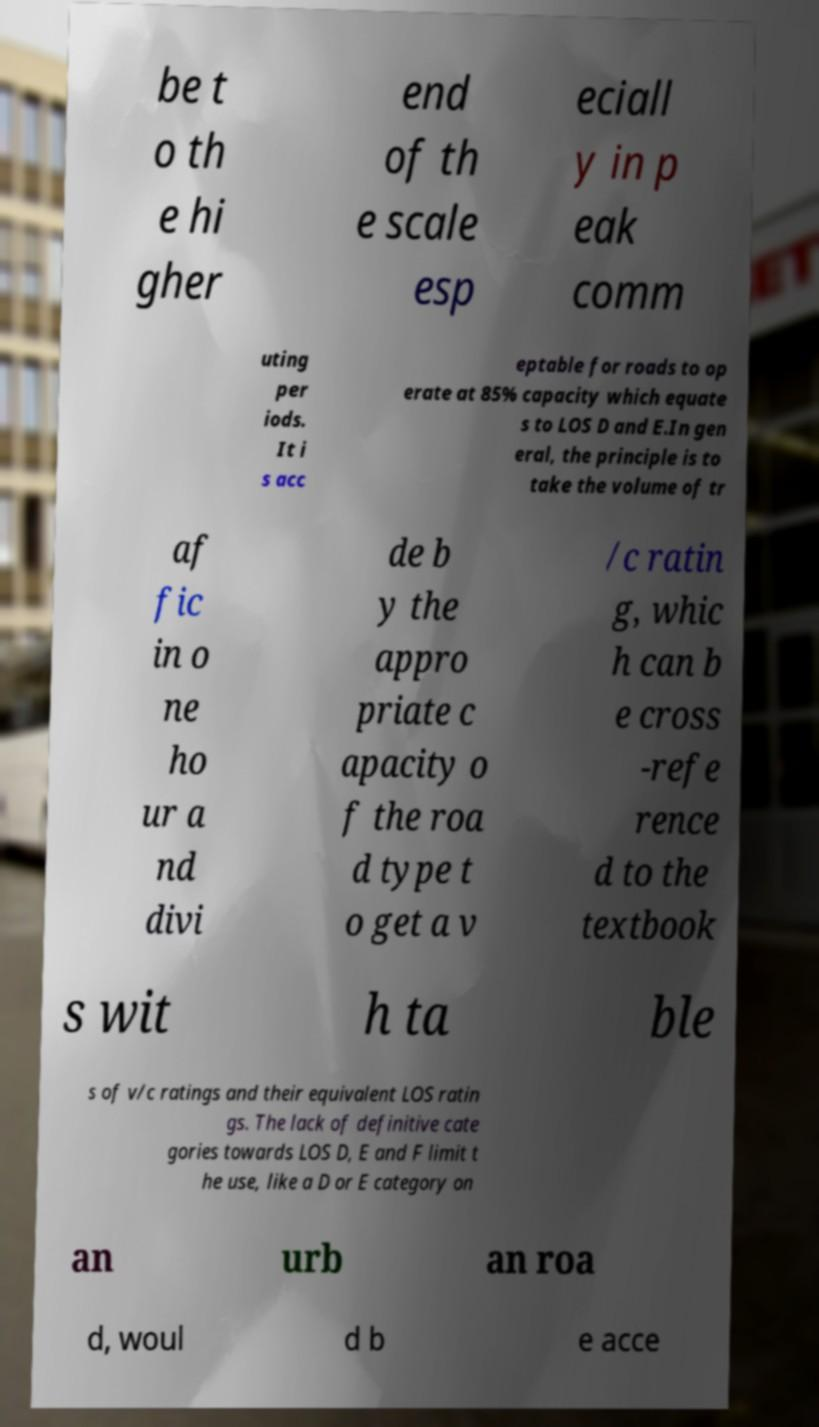There's text embedded in this image that I need extracted. Can you transcribe it verbatim? be t o th e hi gher end of th e scale esp eciall y in p eak comm uting per iods. It i s acc eptable for roads to op erate at 85% capacity which equate s to LOS D and E.In gen eral, the principle is to take the volume of tr af fic in o ne ho ur a nd divi de b y the appro priate c apacity o f the roa d type t o get a v /c ratin g, whic h can b e cross -refe rence d to the textbook s wit h ta ble s of v/c ratings and their equivalent LOS ratin gs. The lack of definitive cate gories towards LOS D, E and F limit t he use, like a D or E category on an urb an roa d, woul d b e acce 